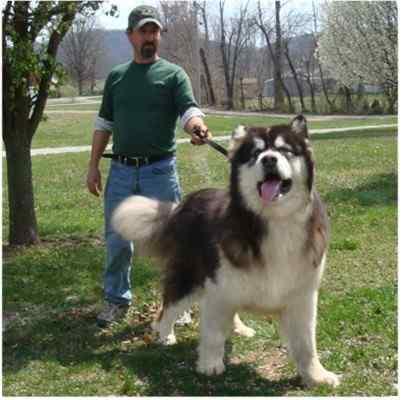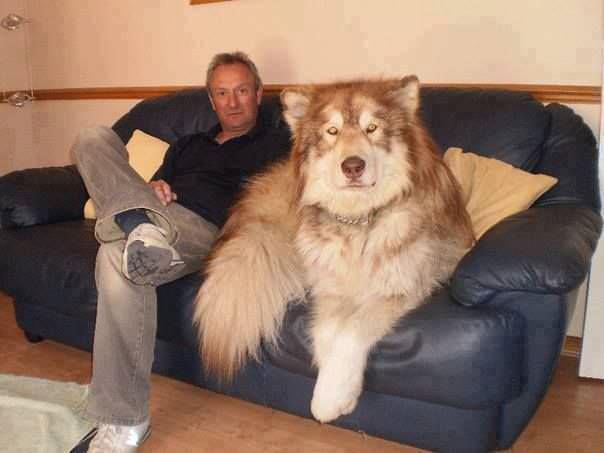The first image is the image on the left, the second image is the image on the right. Examine the images to the left and right. Is the description "There are more dogs in the image on the right." accurate? Answer yes or no. No. The first image is the image on the left, the second image is the image on the right. Given the left and right images, does the statement "Each image includes at least one person sitting close to at least one dog in an indoor setting, and the right image shows dog and human on a sofa." hold true? Answer yes or no. No. 